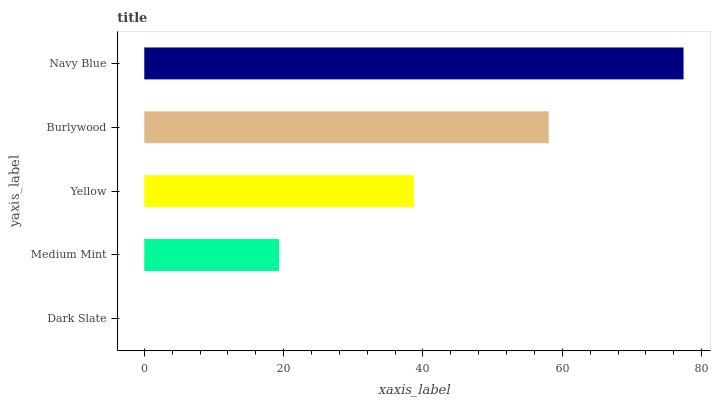Is Dark Slate the minimum?
Answer yes or no. Yes. Is Navy Blue the maximum?
Answer yes or no. Yes. Is Medium Mint the minimum?
Answer yes or no. No. Is Medium Mint the maximum?
Answer yes or no. No. Is Medium Mint greater than Dark Slate?
Answer yes or no. Yes. Is Dark Slate less than Medium Mint?
Answer yes or no. Yes. Is Dark Slate greater than Medium Mint?
Answer yes or no. No. Is Medium Mint less than Dark Slate?
Answer yes or no. No. Is Yellow the high median?
Answer yes or no. Yes. Is Yellow the low median?
Answer yes or no. Yes. Is Medium Mint the high median?
Answer yes or no. No. Is Dark Slate the low median?
Answer yes or no. No. 